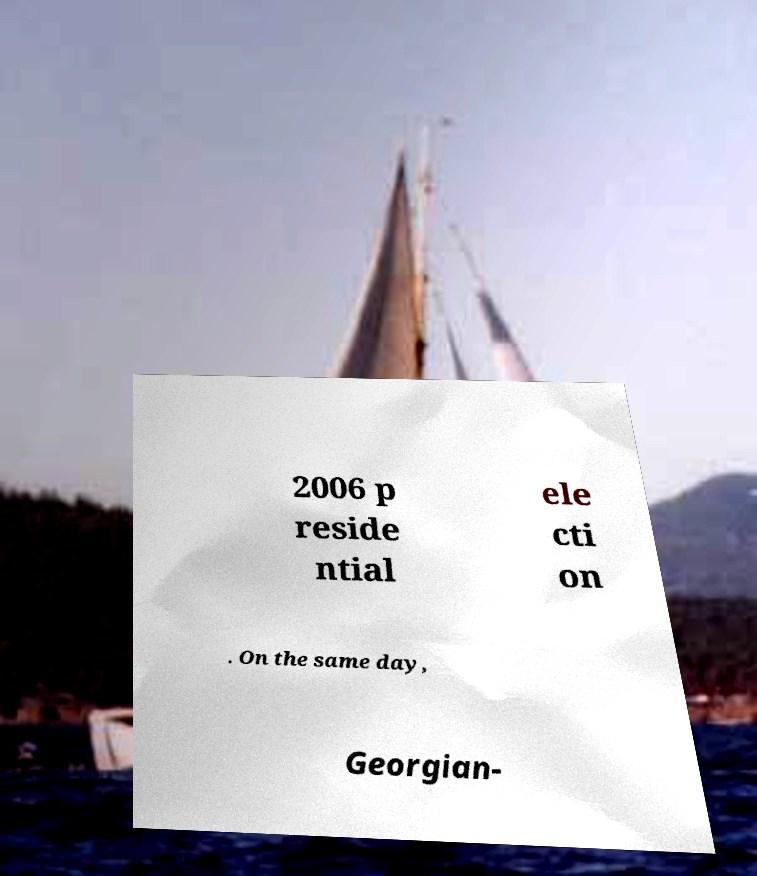For documentation purposes, I need the text within this image transcribed. Could you provide that? 2006 p reside ntial ele cti on . On the same day, Georgian- 